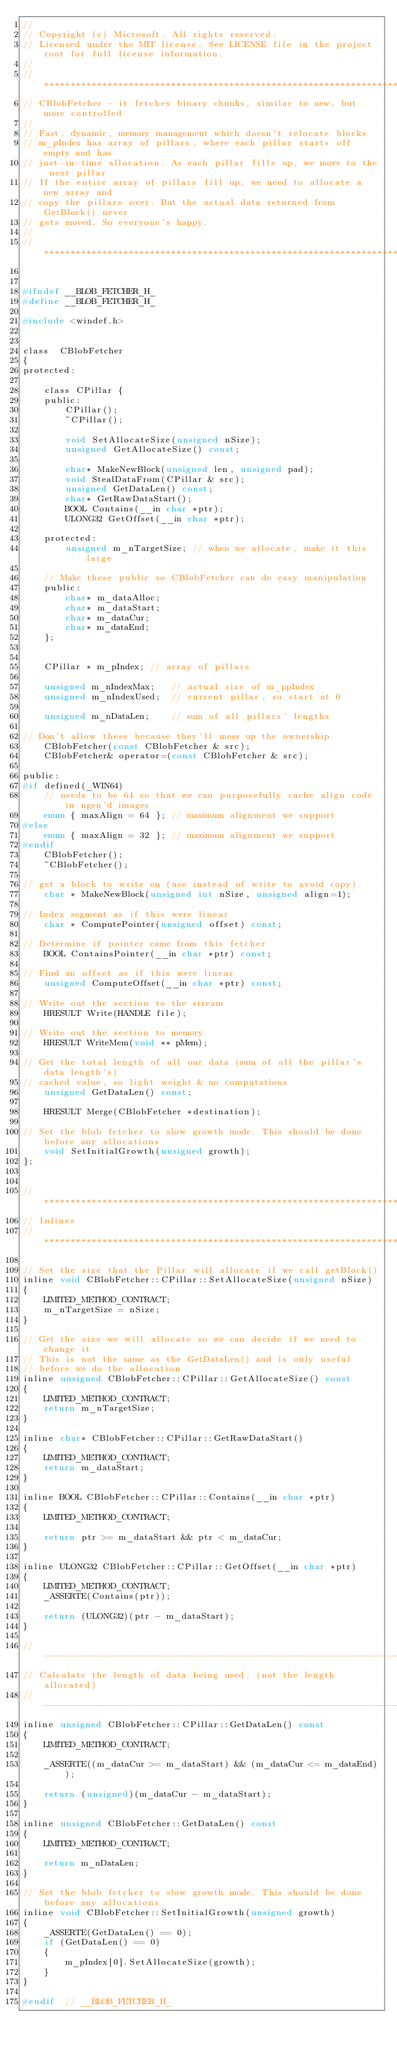<code> <loc_0><loc_0><loc_500><loc_500><_C_>//
// Copyright (c) Microsoft. All rights reserved.
// Licensed under the MIT license. See LICENSE file in the project root for full license information.
//
//*****************************************************************************
// CBlobFetcher - it fetches binary chunks, similar to new, but more controlled
//
// Fast, dynamic, memory management which doesn't relocate blocks
// m_pIndex has array of pillars, where each pillar starts off empty and has
// just-in-time allocation. As each pillar fills up, we move to the next pillar
// If the entire array of pillars fill up, we need to allocate a new array and
// copy the pillars over. But the actual data returned from GetBlock() never
// gets moved. So everyone's happy.
//
//*****************************************************************************


#ifndef __BLOB_FETCHER_H_
#define __BLOB_FETCHER_H_

#include <windef.h>


class  CBlobFetcher
{
protected:

    class CPillar {
    public:
        CPillar();
        ~CPillar();

        void SetAllocateSize(unsigned nSize);
        unsigned GetAllocateSize() const;

        char* MakeNewBlock(unsigned len, unsigned pad);
        void StealDataFrom(CPillar & src);
        unsigned GetDataLen() const;
        char* GetRawDataStart();
        BOOL Contains(__in char *ptr);
        ULONG32 GetOffset(__in char *ptr);

    protected:
        unsigned m_nTargetSize; // when we allocate, make it this large

    // Make these public so CBlobFetcher can do easy manipulation
    public:
        char* m_dataAlloc;
        char* m_dataStart;
        char* m_dataCur;
        char* m_dataEnd;
    };


    CPillar * m_pIndex; // array of pillars

    unsigned m_nIndexMax;   // actual size of m_ppIndex
    unsigned m_nIndexUsed;  // current pillar, so start at 0

    unsigned m_nDataLen;    // sum of all pillars' lengths

// Don't allow these because they'll mess up the ownership
    CBlobFetcher(const CBlobFetcher & src);
    CBlobFetcher& operator=(const CBlobFetcher & src);

public:
#if defined(_WIN64)
    // needs to be 64 so that we can purposefully cache align code in ngen'd images
    enum { maxAlign = 64 }; // maximum alignment we support
#else
    enum { maxAlign = 32 }; // maximum alignment we support
#endif
    CBlobFetcher();
    ~CBlobFetcher();

// get a block to write on (use instead of write to avoid copy)
    char * MakeNewBlock(unsigned int nSize, unsigned align=1);

// Index segment as if this were linear
    char * ComputePointer(unsigned offset) const;

// Determine if pointer came from this fetcher
    BOOL ContainsPointer(__in char *ptr) const;

// Find an offset as if this were linear
    unsigned ComputeOffset(__in char *ptr) const;

// Write out the section to the stream
    HRESULT Write(HANDLE file);

// Write out the section to memory
    HRESULT WriteMem(void ** pMem);

// Get the total length of all our data (sum of all the pillar's data length's) 
// cached value, so light weight & no computations
    unsigned GetDataLen() const;

    HRESULT Merge(CBlobFetcher *destination);

// Set the blob fetcher to slow growth mode. This should be done before any allocations
    void SetInitialGrowth(unsigned growth);
};


//*****************************************************************************
// Inlines
//*****************************************************************************

// Set the size that the Pillar will allocate if we call getBlock()
inline void CBlobFetcher::CPillar::SetAllocateSize(unsigned nSize)
{
    LIMITED_METHOD_CONTRACT;
    m_nTargetSize = nSize;
}

// Get the size we will allocate so we can decide if we need to change it
// This is not the same as the GetDataLen() and is only useful
// before we do the allocation
inline unsigned CBlobFetcher::CPillar::GetAllocateSize() const
{
    LIMITED_METHOD_CONTRACT;
    return m_nTargetSize;
}

inline char* CBlobFetcher::CPillar::GetRawDataStart()
{
    LIMITED_METHOD_CONTRACT;
    return m_dataStart;
}

inline BOOL CBlobFetcher::CPillar::Contains(__in char *ptr)
{
    LIMITED_METHOD_CONTRACT;

    return ptr >= m_dataStart && ptr < m_dataCur;
}

inline ULONG32 CBlobFetcher::CPillar::GetOffset(__in char *ptr)
{
    LIMITED_METHOD_CONTRACT;
    _ASSERTE(Contains(ptr));
    
    return (ULONG32)(ptr - m_dataStart);
}

//-----------------------------------------------------------------------------
// Calculate the length of data being used, (not the length allocated)
//-----------------------------------------------------------------------------
inline unsigned CBlobFetcher::CPillar::GetDataLen() const
{
    LIMITED_METHOD_CONTRACT;

    _ASSERTE((m_dataCur >= m_dataStart) && (m_dataCur <= m_dataEnd));

    return (unsigned)(m_dataCur - m_dataStart);
}

inline unsigned CBlobFetcher::GetDataLen() const
{
    LIMITED_METHOD_CONTRACT;

    return m_nDataLen;
}

// Set the blob fetcher to slow growth mode. This should be done before any allocations
inline void CBlobFetcher::SetInitialGrowth(unsigned growth)
{
    _ASSERTE(GetDataLen() == 0);
    if (GetDataLen() == 0)
    {
        m_pIndex[0].SetAllocateSize(growth);
    }
}

#endif  // __BLOB_FETCHER_H_
</code> 